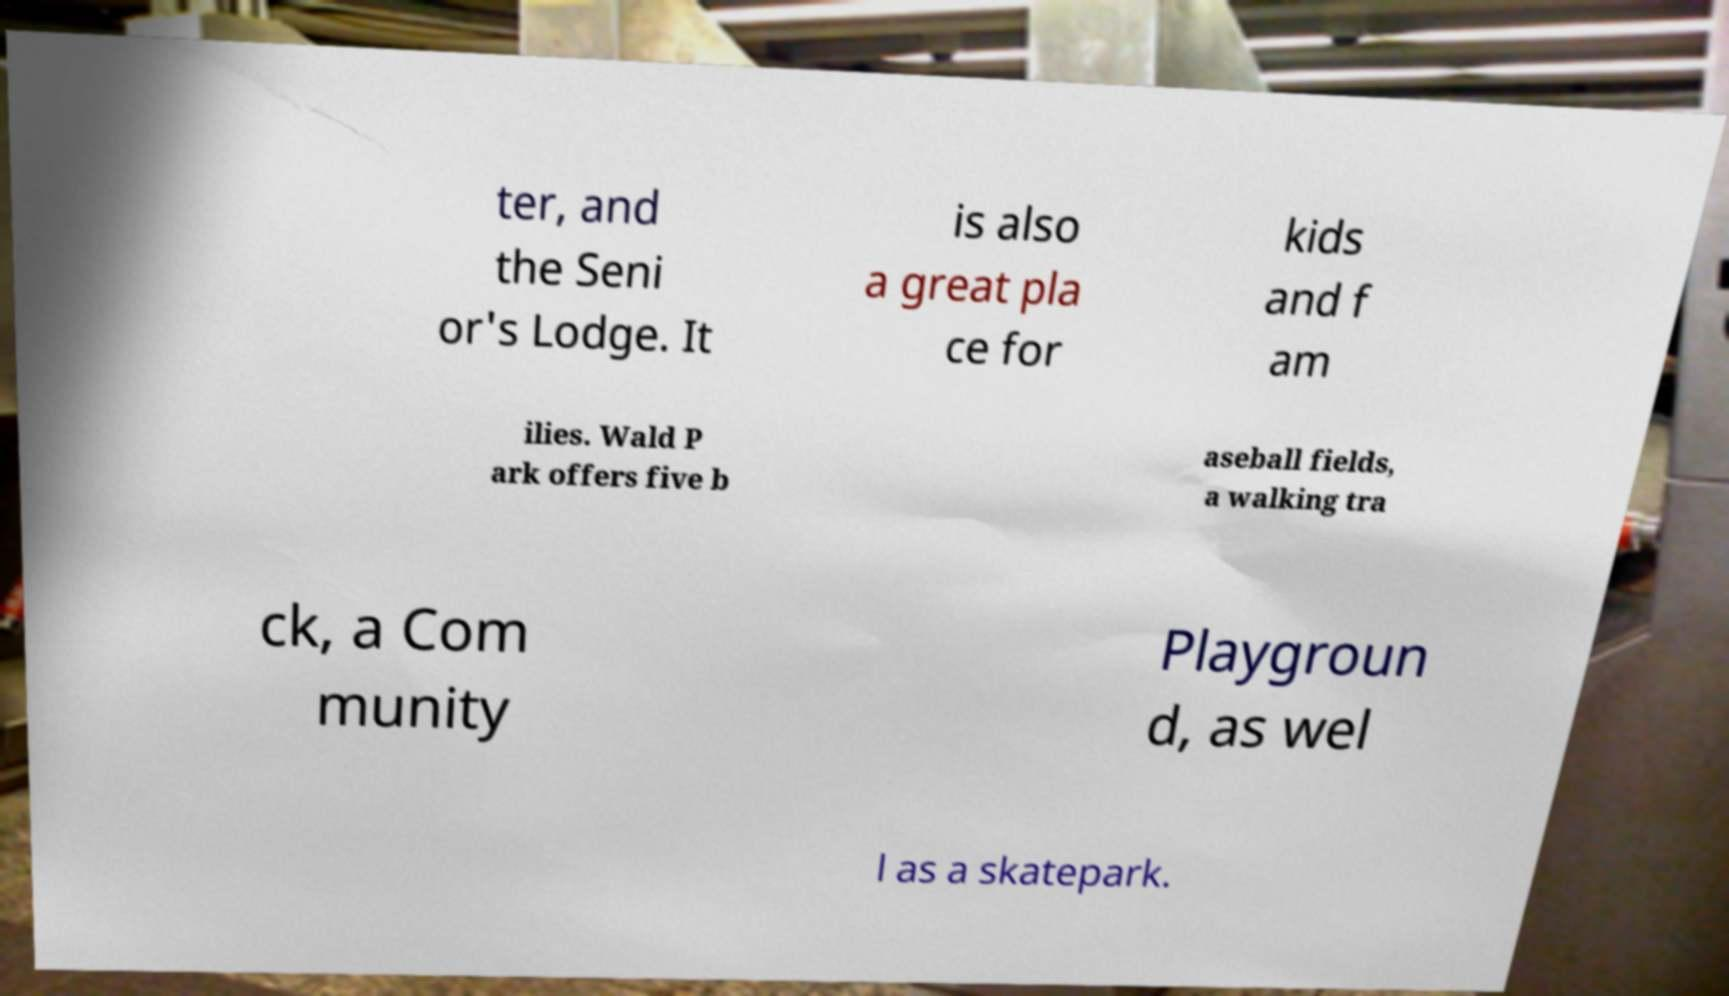Could you assist in decoding the text presented in this image and type it out clearly? ter, and the Seni or's Lodge. It is also a great pla ce for kids and f am ilies. Wald P ark offers five b aseball fields, a walking tra ck, a Com munity Playgroun d, as wel l as a skatepark. 